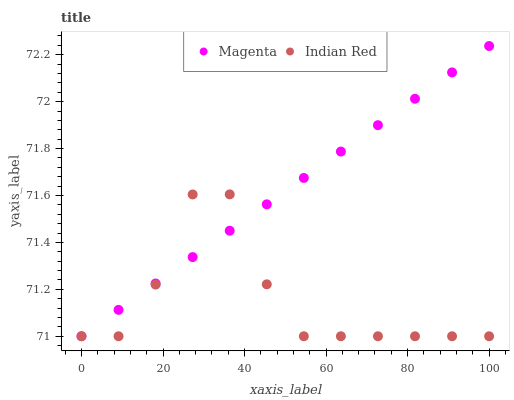Does Indian Red have the minimum area under the curve?
Answer yes or no. Yes. Does Magenta have the maximum area under the curve?
Answer yes or no. Yes. Does Indian Red have the maximum area under the curve?
Answer yes or no. No. Is Magenta the smoothest?
Answer yes or no. Yes. Is Indian Red the roughest?
Answer yes or no. Yes. Is Indian Red the smoothest?
Answer yes or no. No. Does Magenta have the lowest value?
Answer yes or no. Yes. Does Magenta have the highest value?
Answer yes or no. Yes. Does Indian Red have the highest value?
Answer yes or no. No. Does Indian Red intersect Magenta?
Answer yes or no. Yes. Is Indian Red less than Magenta?
Answer yes or no. No. Is Indian Red greater than Magenta?
Answer yes or no. No. 